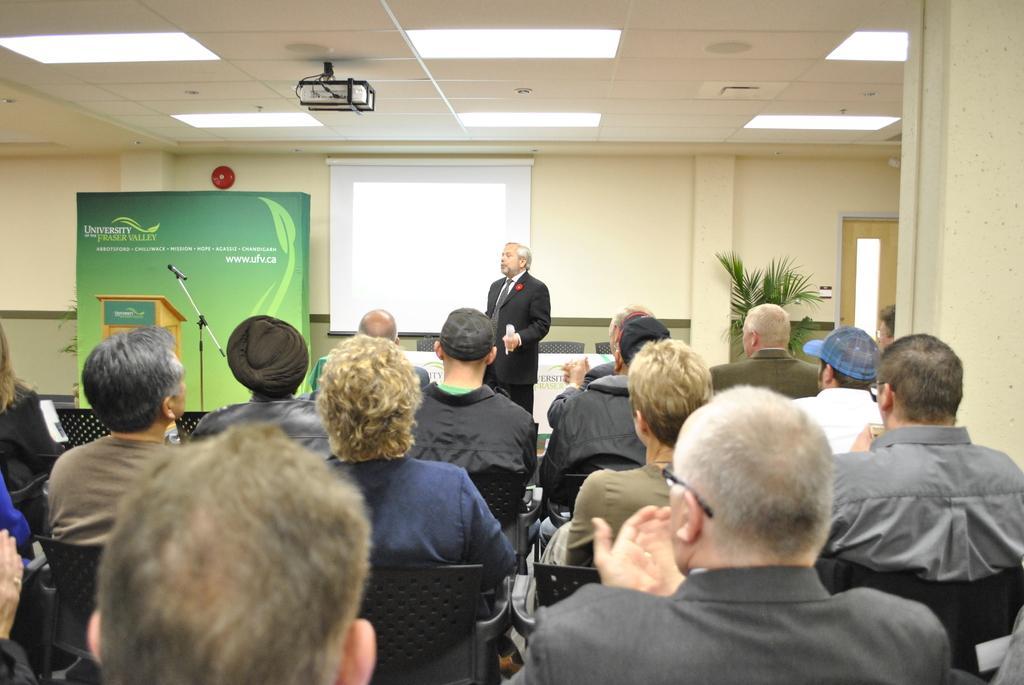How would you summarize this image in a sentence or two? In this image there are people sitting on the chairs. In front of them there is a man standing. Behind him there are chairs and a table. In the background there is a wall. There is a protector board hanging to the wall. To the left there is a board near to the wall. In front of that board there is a podium. Beside the podium there is a microphone to its stand. There are lights to the ceiling. To the right there is a door to the wall. Beside the door there is a houseplant. 